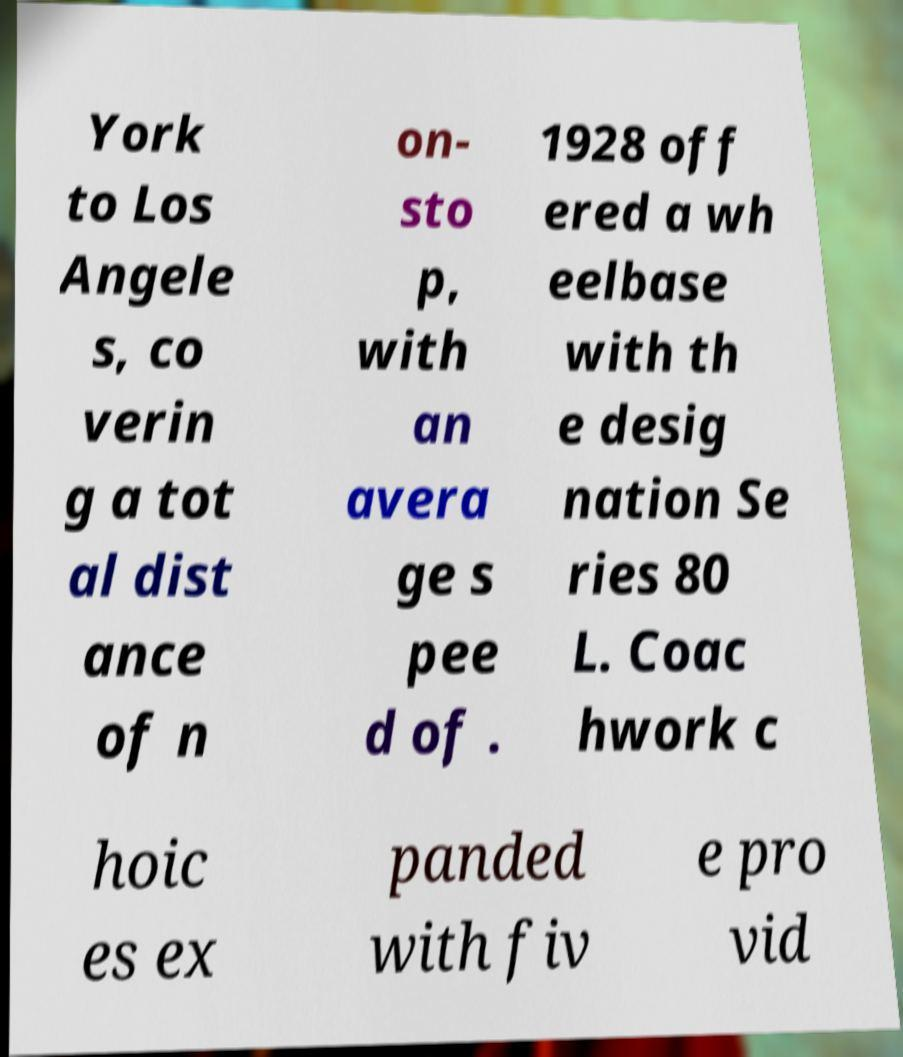Can you accurately transcribe the text from the provided image for me? York to Los Angele s, co verin g a tot al dist ance of n on- sto p, with an avera ge s pee d of . 1928 off ered a wh eelbase with th e desig nation Se ries 80 L. Coac hwork c hoic es ex panded with fiv e pro vid 